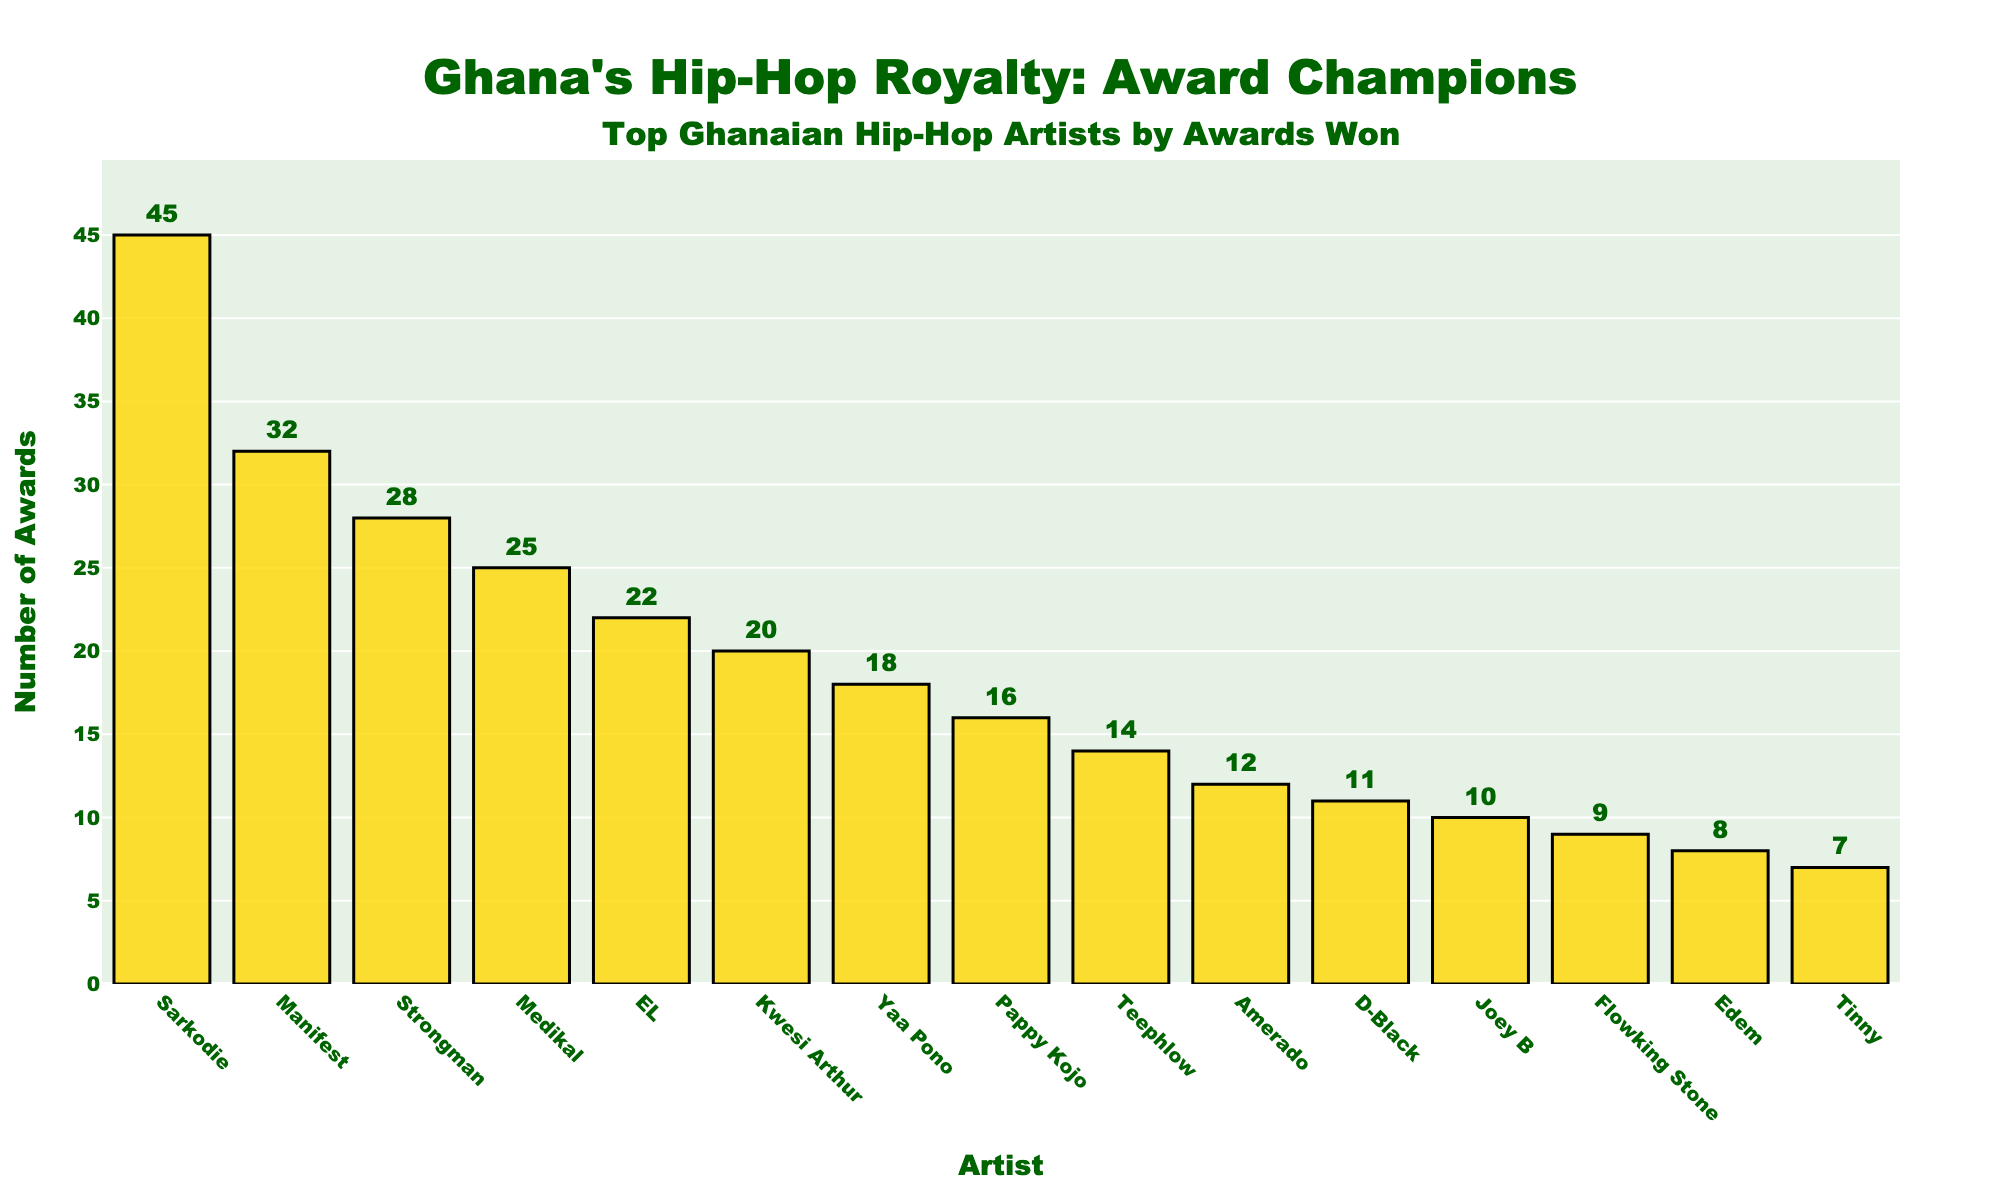Which artist has won the most awards? Sarkodie's bar is the tallest on the chart.
Answer: Sarkodie Which two artists have a combined total of awards closest to 50? Manifest and Strongman have 32 and 28 awards respectively. Their combined total is 60, which closely approximates the value.
Answer: Manifest and Strongman Who has more awards: EL or Yaa Pono? EL has 22 awards, while Yaa Pono has 18.
Answer: EL What's the difference in the number of awards between Medikal and Kwesi Arthur? Medikal has 25 awards and Kwesi Arthur has 20. The difference is 25 - 20 = 5.
Answer: 5 Which artists are in the top 5 by the number of awards won? The top 5 artists, with the tallest bars, are Sarkodie, Manifest, Strongman, Medikal, and EL.
Answer: Sarkodie, Manifest, Strongman, Medikal, EL Which artist has the least number of awards in the top 10? Amerado has the shortest bar in the top 10 with 12 awards.
Answer: Amerado How many more awards does Pappy Kojo have compared to Tinny? Pappy Kojo has 16 awards and Tinny has 7. The difference is 16 - 7 = 9.
Answer: 9 Between Strongman and Joey B, who has more awards and by how many? Strongman has 28 awards, and Joey B has 10. The difference is 28 - 10 = 18.
Answer: Strongman, 18 How many awards have Kwesi Arthur, Yaa Pono, and Pappy Kojo won in total? Add their award counts: Kwesi Arthur (20) + Yaa Pono (18) + Pappy Kojo (16) = 54.
Answer: 54 What is the range of the awards won by the top 10 artists? The maximum number of awards is 45 (Sarkodie) and the minimum is 12 (Amerado). The range is 45 - 12 = 33.
Answer: 33 